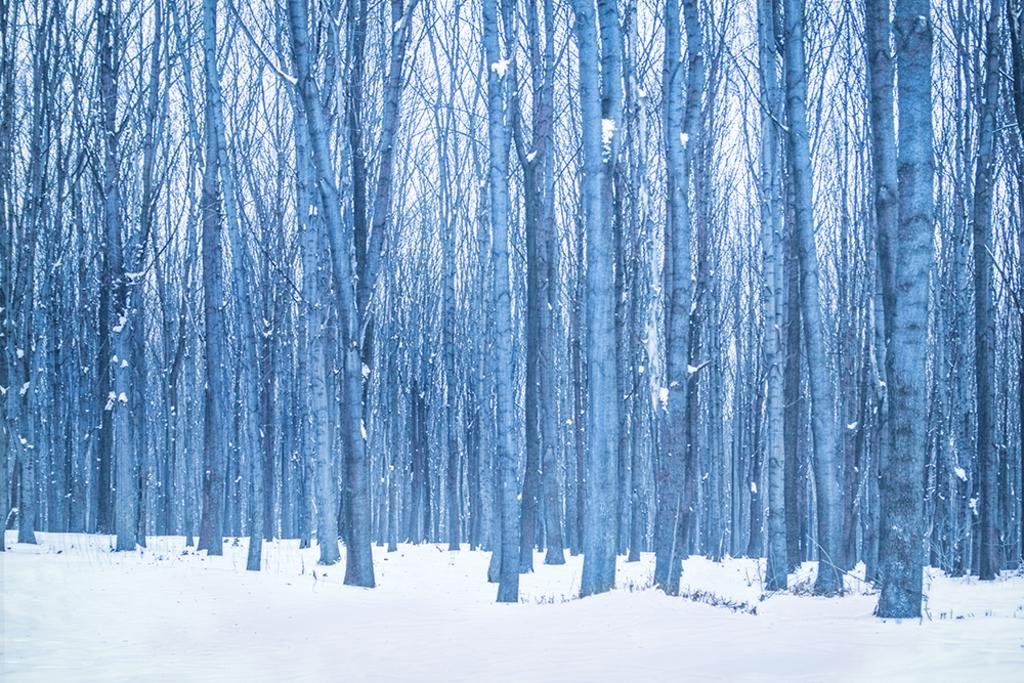What type of vegetation can be seen in the image? There are trees in the image. What is covering the ground in the image? There appears to be snow at the bottom of the image. How long does it take for the dog to walk across the image? There is no dog present in the image, so it is not possible to answer this question. 